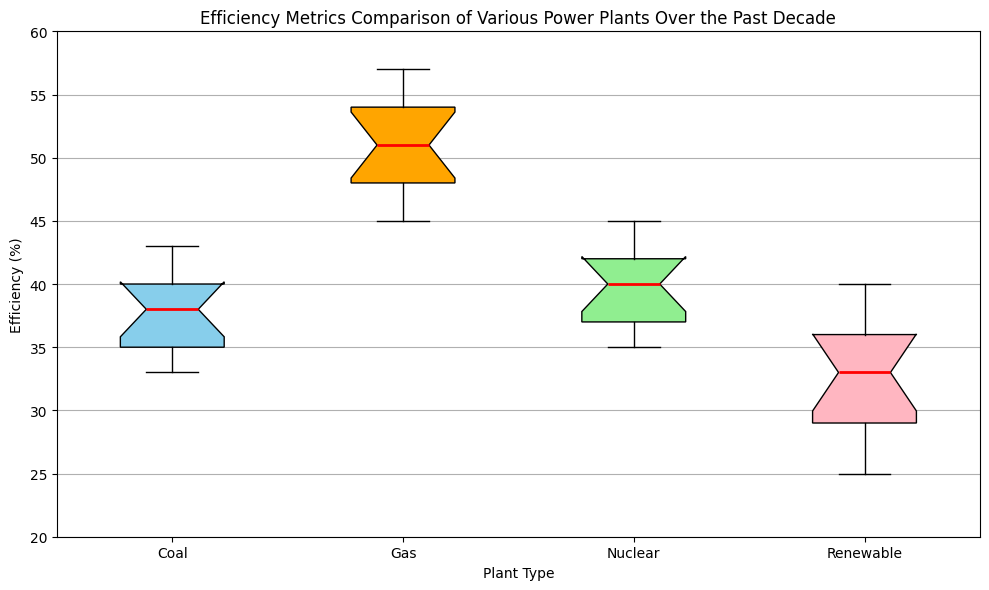What is the median efficiency of each plant type? The median efficiency for each plant type can be determined by looking at the line inside each box in the box plot. For Coal, Gas, Nuclear, and Renewable, visually identify the center line inside each box.
Answer: Coal: 37.5, Gas: 51.5, Nuclear: 39.5, Renewable: 32 Which plant type has the highest median efficiency over the past decade? The highest median efficiency is represented by the highest center line among the boxes in the plot. The Gas plant has the highest center line in its box.
Answer: Gas Which plant type has the lowest median efficiency over the past decade? The lowest median efficiency is represented by the lowest center line among the boxes in the plot. The Renewable plant has the lowest center line in its box.
Answer: Renewable How does the efficiency range for Nuclear plants compare to the efficiency range for Gas plants? The efficiency range can be seen from the top to the bottom of the whiskers (the lines extending from the boxes). For Nuclear, the range is from about 35 to 45. For Gas, it is from about 45 to 57. The Nuclear range is narrower compared to Gas.
Answer: Nuclear range is narrower than Gas What are the lower and upper quartiles for Coal plants' efficiency? The lower quartile (Q1) is the bottom of the box, and the upper quartile (Q3) is the top of the box for Coal plants. Check the bottom and top of the Coal box.
Answer: Q1: 35.5, Q3: 39.5 Which plant type shows the most variability in efficiency? The most variability can be identified by the length of the box (distance between Q1 and Q3) and the whiskers. The Gas plant box and whiskers cover the largest range, indicating the most variability.
Answer: Gas Are there any outliers in the data for any plant type? Outliers are represented by points outside the whiskers. By visually inspecting the plot, there are no points outside the whiskers for any plant type.
Answer: No What is the difference between the maximum efficiency of Coal and Renewable plants? The maximum values can be identified by the top whisker of each box. For Coal, it is about 43, and for Renewable, it is about 40. The difference is 43 - 40.
Answer: 3 Is the efficiency of Renewable plants improving over the past decade, according to the median values? Check the center line (median) inside the Renewable plants’ box. It shows a gradually increasing trend from left to right over the years.
Answer: Yes 